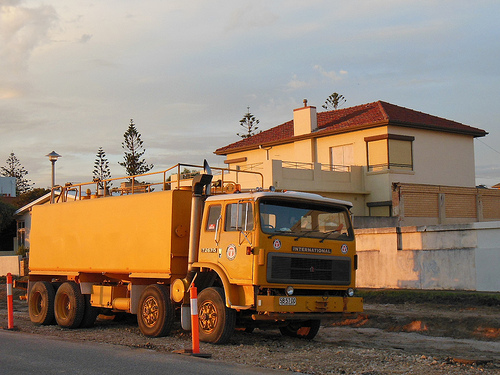What does the sunset light indicate about the time of day and how does it affect the appearance of the truck? The warm, golden hue of the sunset light suggests it's late afternoon or early evening. This kind of lighting casts long shadows and enhances the yellow color of the truck, giving the entire scene a nostalgic and serene ambiance. 